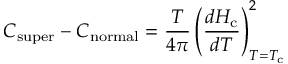<formula> <loc_0><loc_0><loc_500><loc_500>C _ { s u p e r } - C _ { n o r m a l } = { \frac { T } { 4 \pi } } \left ( { \frac { d H _ { c } } { d T } } \right ) _ { T = T _ { c } } ^ { 2 }</formula> 